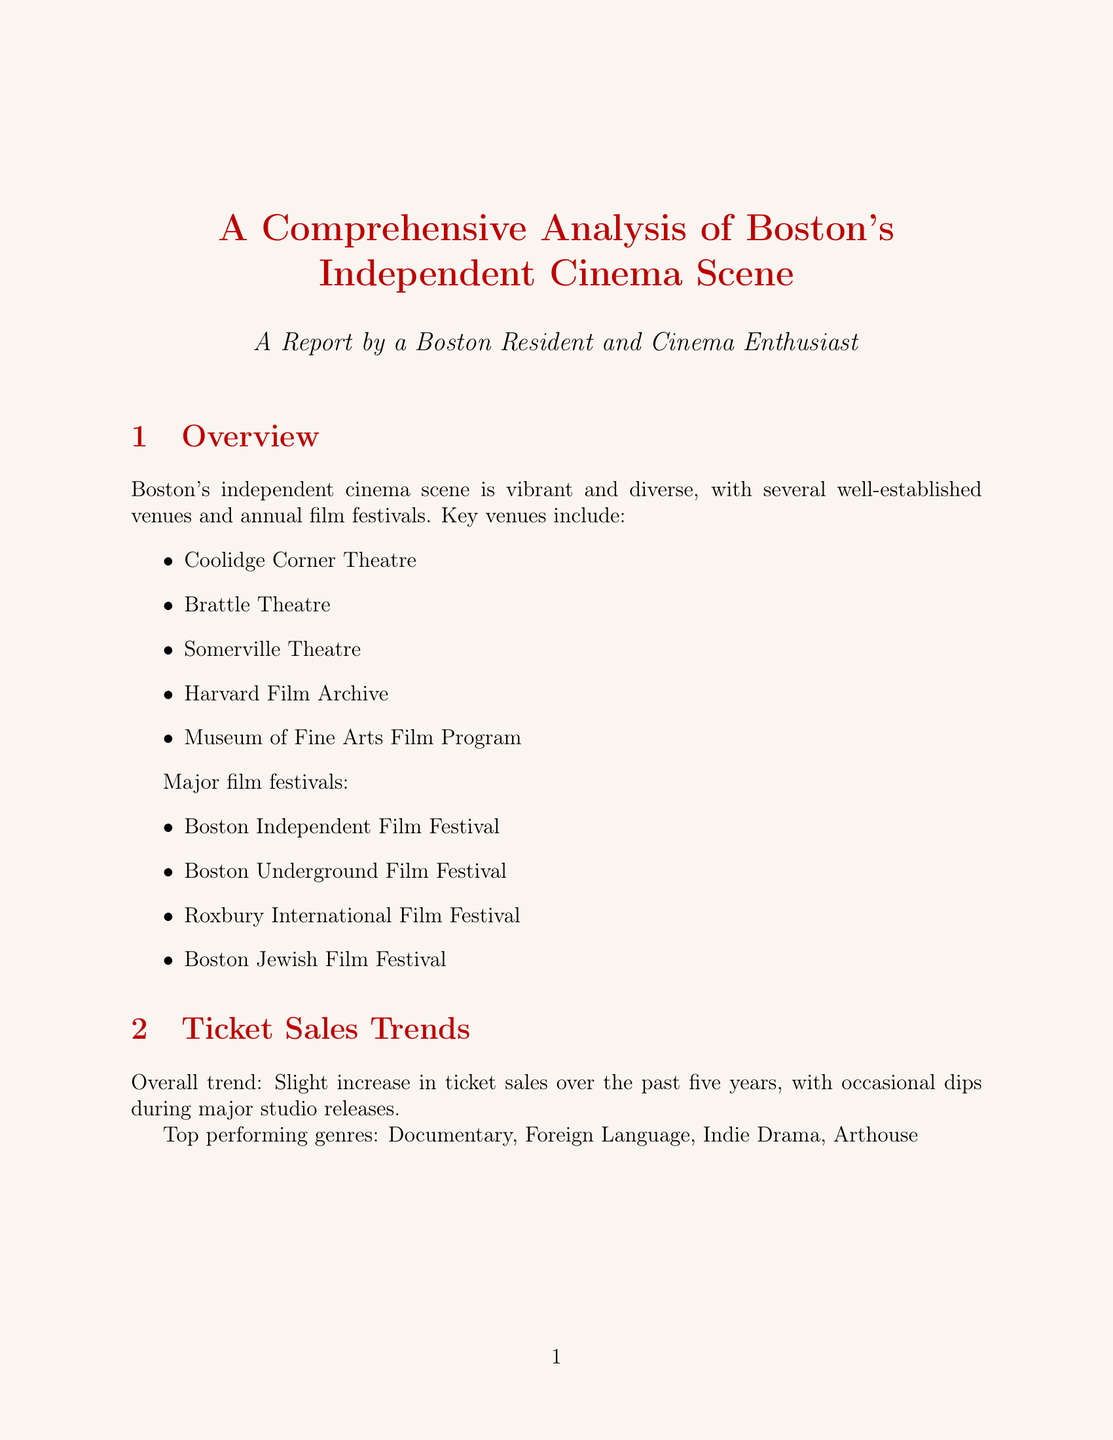What are the key venues in Boston's independent cinema scene? The document lists several key venues that represent Boston's independent cinema scene, which include Coolidge Corner Theatre, Brattle Theatre, Somerville Theatre, Harvard Film Archive, and Museum of Fine Arts Film Program.
Answer: Coolidge Corner Theatre, Brattle Theatre, Somerville Theatre, Harvard Film Archive, Museum of Fine Arts Film Program What was the total ticket sales in 2019? The document provides yearly data on ticket sales and states that the total tickets sold in 2019 was 535,000.
Answer: 535000 Which age group makes up the largest percentage of the audience? The audience demographics section reveals that the age group 25-34 constitutes the largest percentage (31%) of the audience.
Answer: 25-34 What was the percentage change in ticket sales from 2020 to 2021? The document shows that there was a 46.4% increase in ticket sales from 2020 to 2021, indicating a recovery after the significant drop in 2020.
Answer: +46.4% What unique aspect is highlighted related to the academic influence in Boston's cinema scene? The document mentions a strong academic influence due to the presence of university film programs and student audiences from institutions like Harvard, MIT, and Boston University.
Answer: Strong presence of university film programs What percentage of the audience attends films once a month? The frequency of attendance data indicates that 35% of the audience attends films once a month.
Answer: 35% What are some challenges faced by Boston's independent cinema scene? The document identifies several challenges, including competition from streaming services, high operating costs, and maintaining historic venues.
Answer: Competition from streaming services What is the projected growth rate for ticket sales over the next five years? The future outlook section forecasts a modest growth of 3-5% in ticket sales annually over the next five years.
Answer: 3-5% What is a notable trend regarding emerging filmmakers in the future outlook? The document mentions an increased focus on diverse and underrepresented filmmakers as an emerging trend in the cinema scene.
Answer: Increased focus on diverse and underrepresented filmmakers 